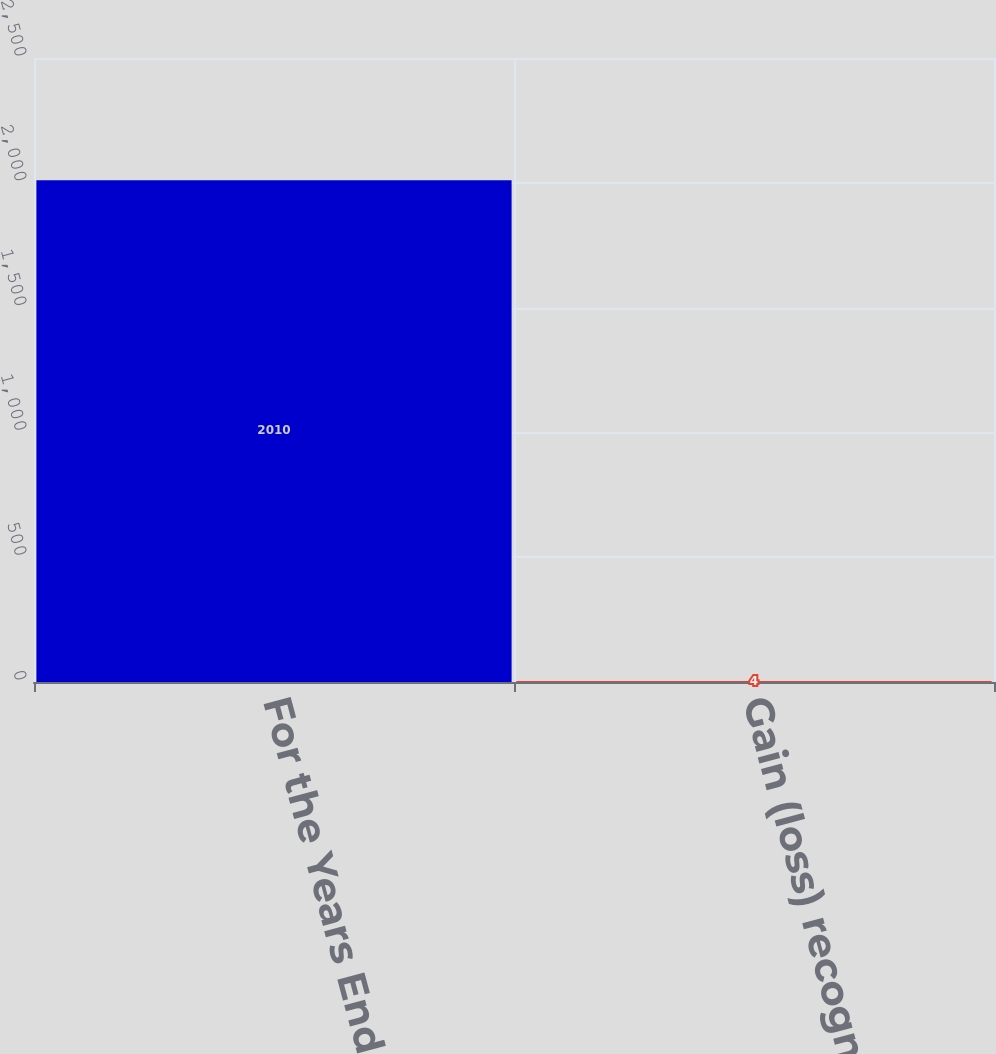Convert chart to OTSL. <chart><loc_0><loc_0><loc_500><loc_500><bar_chart><fcel>For the Years Ended December<fcel>Gain (loss) recognized in<nl><fcel>2010<fcel>4<nl></chart> 